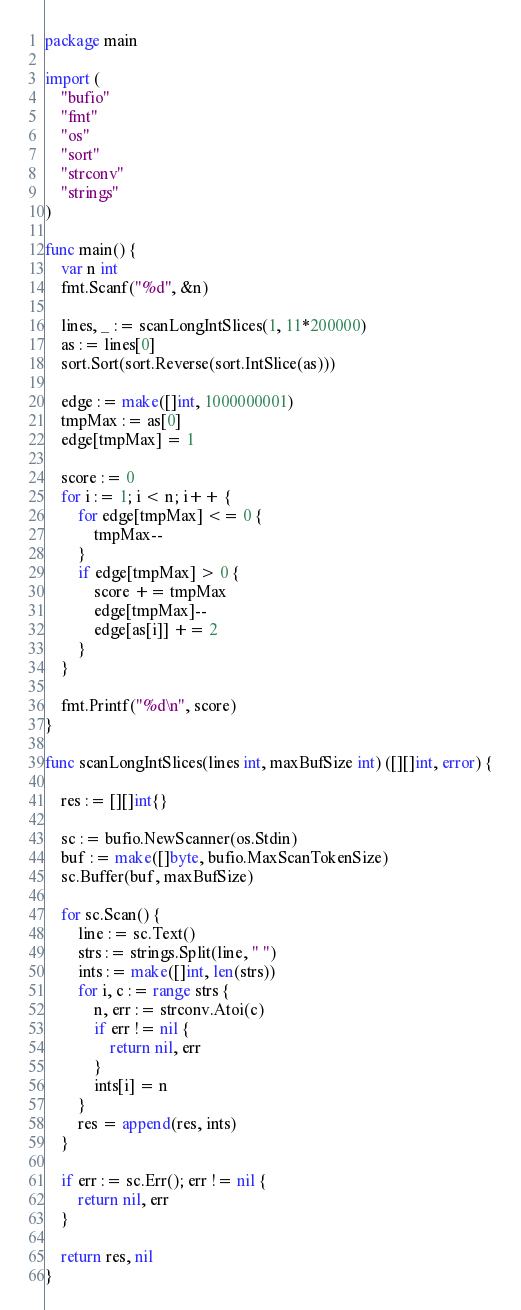Convert code to text. <code><loc_0><loc_0><loc_500><loc_500><_Go_>package main

import (
	"bufio"
	"fmt"
	"os"
	"sort"
	"strconv"
	"strings"
)

func main() {
	var n int
	fmt.Scanf("%d", &n)

	lines, _ := scanLongIntSlices(1, 11*200000)
	as := lines[0]
	sort.Sort(sort.Reverse(sort.IntSlice(as)))

	edge := make([]int, 1000000001)
	tmpMax := as[0]
	edge[tmpMax] = 1

	score := 0
	for i := 1; i < n; i++ {
		for edge[tmpMax] <= 0 {
			tmpMax--
		}
		if edge[tmpMax] > 0 {
			score += tmpMax
			edge[tmpMax]--
			edge[as[i]] += 2
		}
	}

	fmt.Printf("%d\n", score)
}

func scanLongIntSlices(lines int, maxBufSize int) ([][]int, error) {

	res := [][]int{}

	sc := bufio.NewScanner(os.Stdin)
	buf := make([]byte, bufio.MaxScanTokenSize)
	sc.Buffer(buf, maxBufSize)

	for sc.Scan() {
		line := sc.Text()
		strs := strings.Split(line, " ")
		ints := make([]int, len(strs))
		for i, c := range strs {
			n, err := strconv.Atoi(c)
			if err != nil {
				return nil, err
			}
			ints[i] = n
		}
		res = append(res, ints)
	}

	if err := sc.Err(); err != nil {
		return nil, err
	}

	return res, nil
}
</code> 